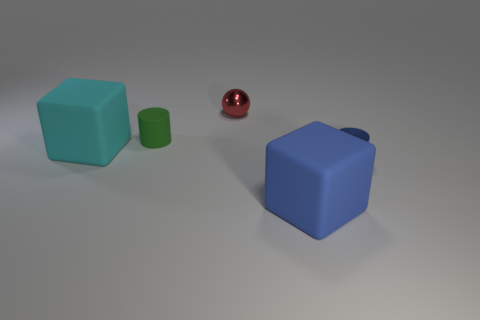Subtract all blue cubes. How many cubes are left? 1 Add 2 big yellow shiny balls. How many objects exist? 7 Subtract all balls. How many objects are left? 4 Subtract 2 cylinders. How many cylinders are left? 0 Subtract all green cylinders. Subtract all brown spheres. How many cylinders are left? 1 Subtract all green blocks. How many yellow cylinders are left? 0 Subtract all big yellow things. Subtract all large blue things. How many objects are left? 4 Add 3 small blue shiny cylinders. How many small blue shiny cylinders are left? 4 Add 3 rubber cylinders. How many rubber cylinders exist? 4 Subtract 0 gray spheres. How many objects are left? 5 